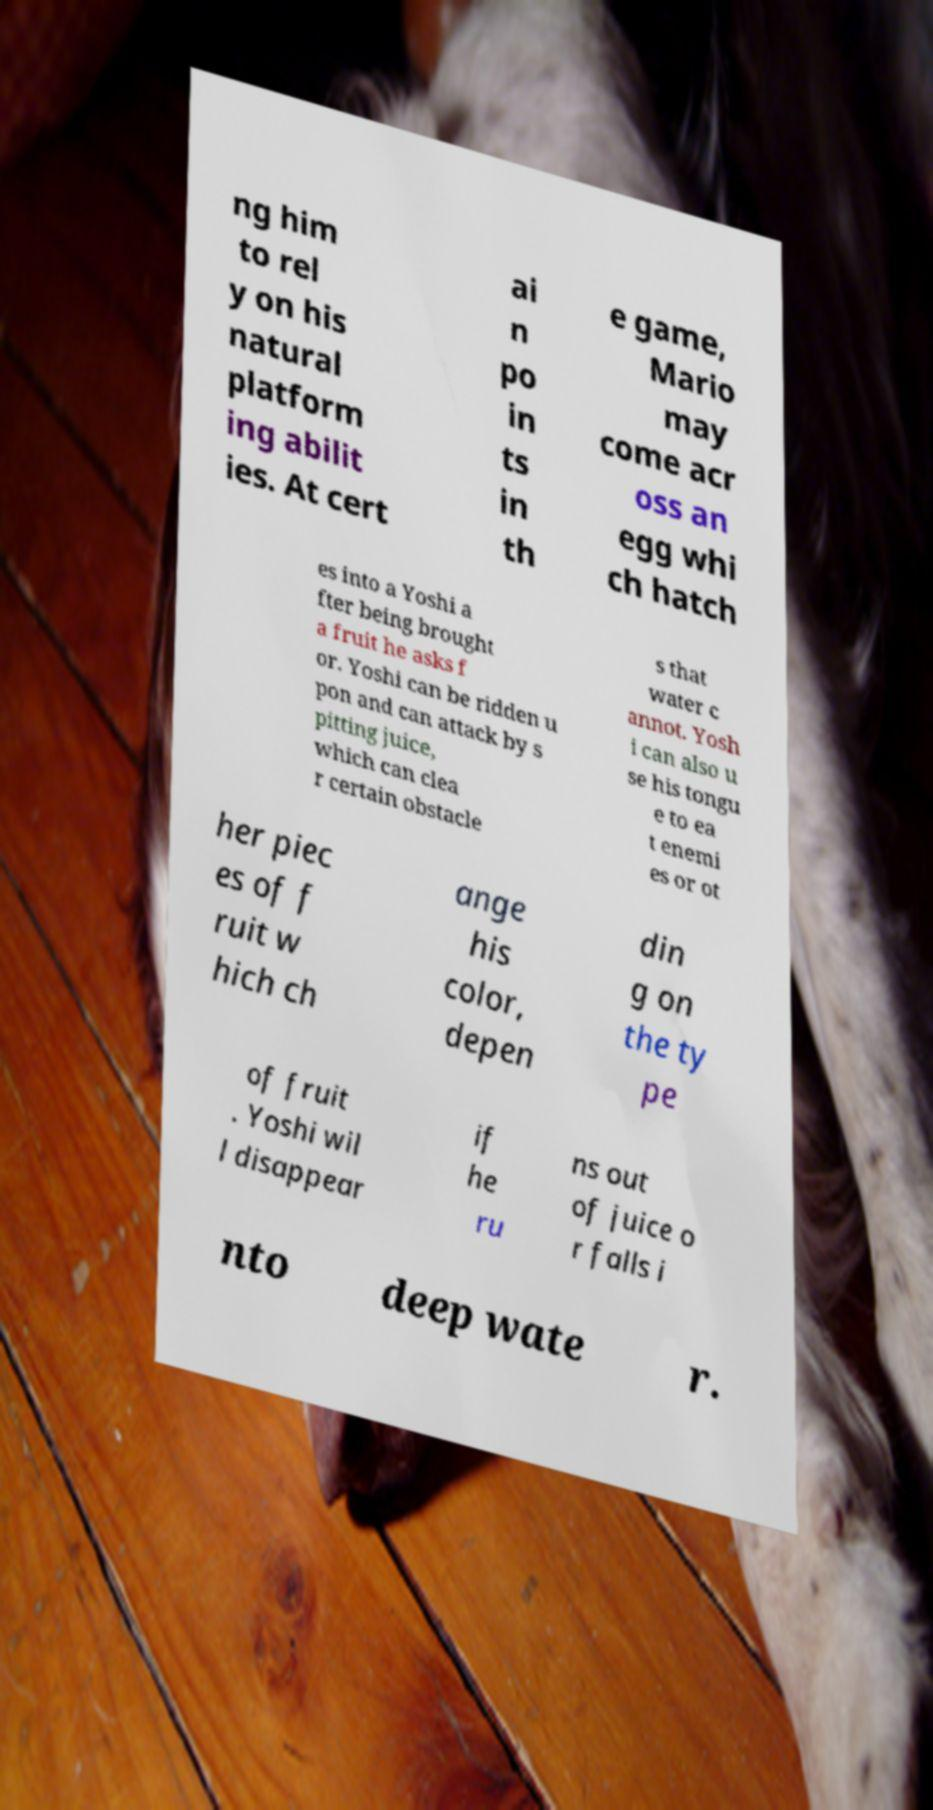I need the written content from this picture converted into text. Can you do that? ng him to rel y on his natural platform ing abilit ies. At cert ai n po in ts in th e game, Mario may come acr oss an egg whi ch hatch es into a Yoshi a fter being brought a fruit he asks f or. Yoshi can be ridden u pon and can attack by s pitting juice, which can clea r certain obstacle s that water c annot. Yosh i can also u se his tongu e to ea t enemi es or ot her piec es of f ruit w hich ch ange his color, depen din g on the ty pe of fruit . Yoshi wil l disappear if he ru ns out of juice o r falls i nto deep wate r. 